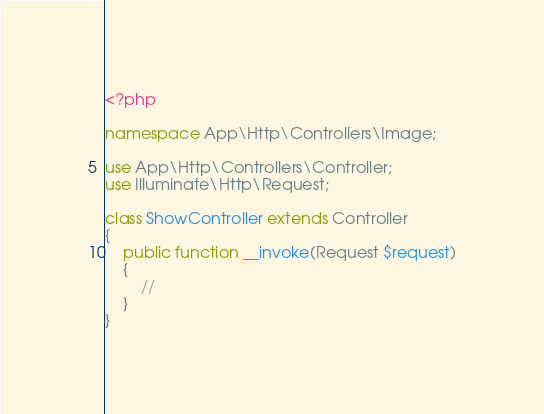<code> <loc_0><loc_0><loc_500><loc_500><_PHP_><?php

namespace App\Http\Controllers\Image;

use App\Http\Controllers\Controller;
use Illuminate\Http\Request;

class ShowController extends Controller
{
    public function __invoke(Request $request)
    {
        //
    }
}
</code> 